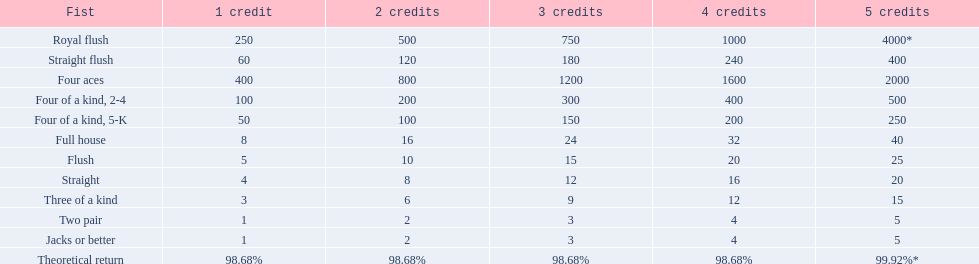What is the higher amount of points for one credit you can get from the best four of a kind 100. What type is it? Four of a kind, 2-4. 